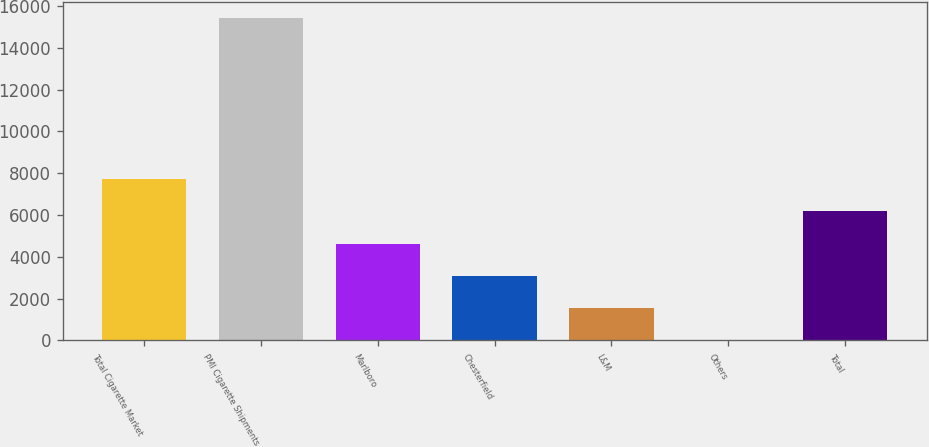<chart> <loc_0><loc_0><loc_500><loc_500><bar_chart><fcel>Total Cigarette Market<fcel>PMI Cigarette Shipments<fcel>Marlboro<fcel>Chesterfield<fcel>L&M<fcel>Others<fcel>Total<nl><fcel>7718.25<fcel>15435<fcel>4631.55<fcel>3088.2<fcel>1544.85<fcel>1.5<fcel>6174.9<nl></chart> 